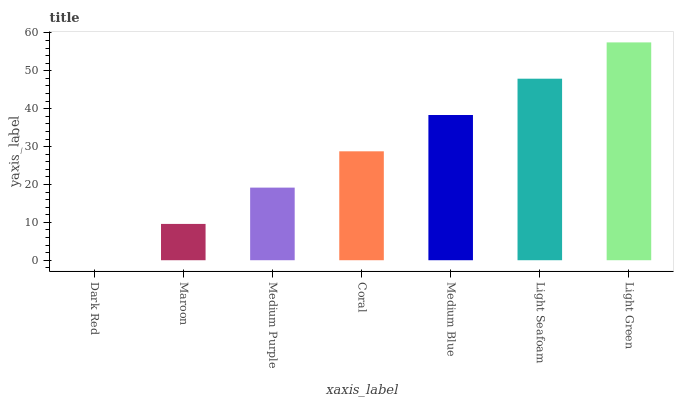Is Dark Red the minimum?
Answer yes or no. Yes. Is Light Green the maximum?
Answer yes or no. Yes. Is Maroon the minimum?
Answer yes or no. No. Is Maroon the maximum?
Answer yes or no. No. Is Maroon greater than Dark Red?
Answer yes or no. Yes. Is Dark Red less than Maroon?
Answer yes or no. Yes. Is Dark Red greater than Maroon?
Answer yes or no. No. Is Maroon less than Dark Red?
Answer yes or no. No. Is Coral the high median?
Answer yes or no. Yes. Is Coral the low median?
Answer yes or no. Yes. Is Medium Purple the high median?
Answer yes or no. No. Is Light Green the low median?
Answer yes or no. No. 